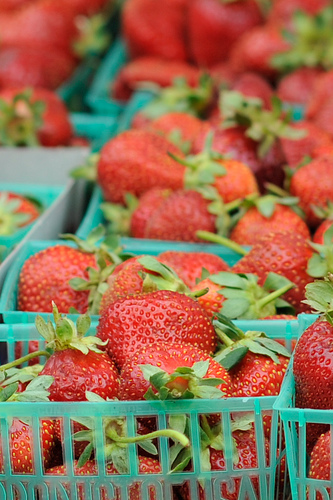<image>
Can you confirm if the strawberry is in the box? Yes. The strawberry is contained within or inside the box, showing a containment relationship. 